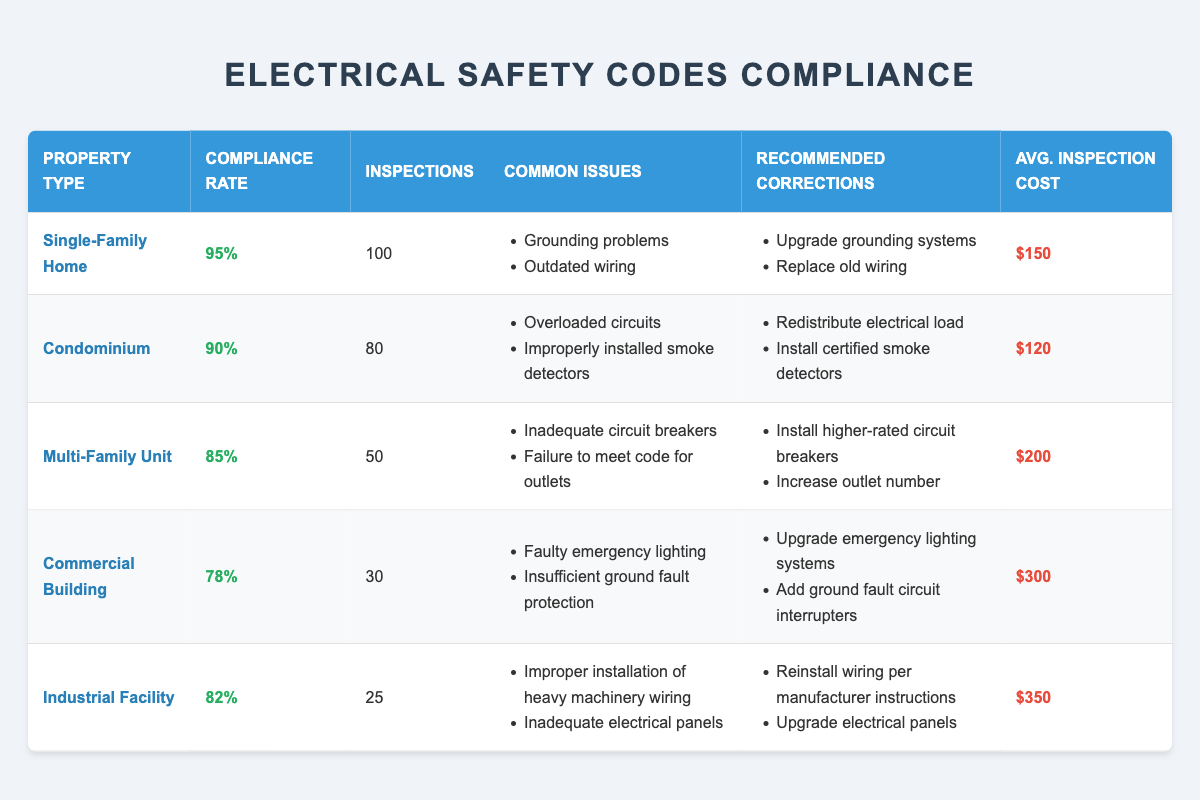What is the compliance rate for Single-Family Homes? The compliance rate for Single-Family Homes is listed directly in the table under the 'Compliance Rate' column for that property type.
Answer: 95% How many inspections were conducted for Commercial Buildings? The number of inspections for Commercial Buildings is found in the table under the 'Inspections' column for that property type.
Answer: 30 What property type has the highest average inspection cost? By comparing the 'Avg. Inspection Cost' column, we can see that Industrial Facilities have the highest average inspection cost of $350.
Answer: Industrial Facility Are there any property types with a compliance rate below 80%? Checking the 'Compliance Rate' column, only the Commercial Building has a compliance rate of 78%, which is below 80%.
Answer: Yes What is the difference in compliance rates between Single-Family Homes and Multi-Family Units? The compliance rate for Single-Family Homes is 95% and for Multi-Family Units, it is 85%. The difference is calculated by subtracting the compliance rate of Multi-Family Units from that of Single-Family Homes: 95% - 85% = 10%.
Answer: 10% What is the average compliance rate for all property types listed? To find the average compliance rate, we add the compliance rates of all property types: (95% + 90% + 85% + 78% + 82%) = 430%. There are 5 property types, so we divide by 5: 430% / 5 = 86%.
Answer: 86% Which property type has common issues related to fire safety equipment? The table indicates that Condominiums have common issues with improperly installed smoke detectors, which is related to fire safety.
Answer: Condominium What is the recommended correction for overloaded circuits? Under the 'Recommended Corrections' column for the Condominium property type, it suggests redistributing electrical load to address overloaded circuits.
Answer: Redistribute electrical load How many total inspections were conducted across all property types? We sum the 'Inspections' column values: 100 + 80 + 50 + 30 + 25 = 285.
Answer: 285 Which property type has the least common issues? The property type with the least common issues is the Single-Family Home, which has only two issues: grounding problems and outdated wiring.
Answer: Single-Family Home 